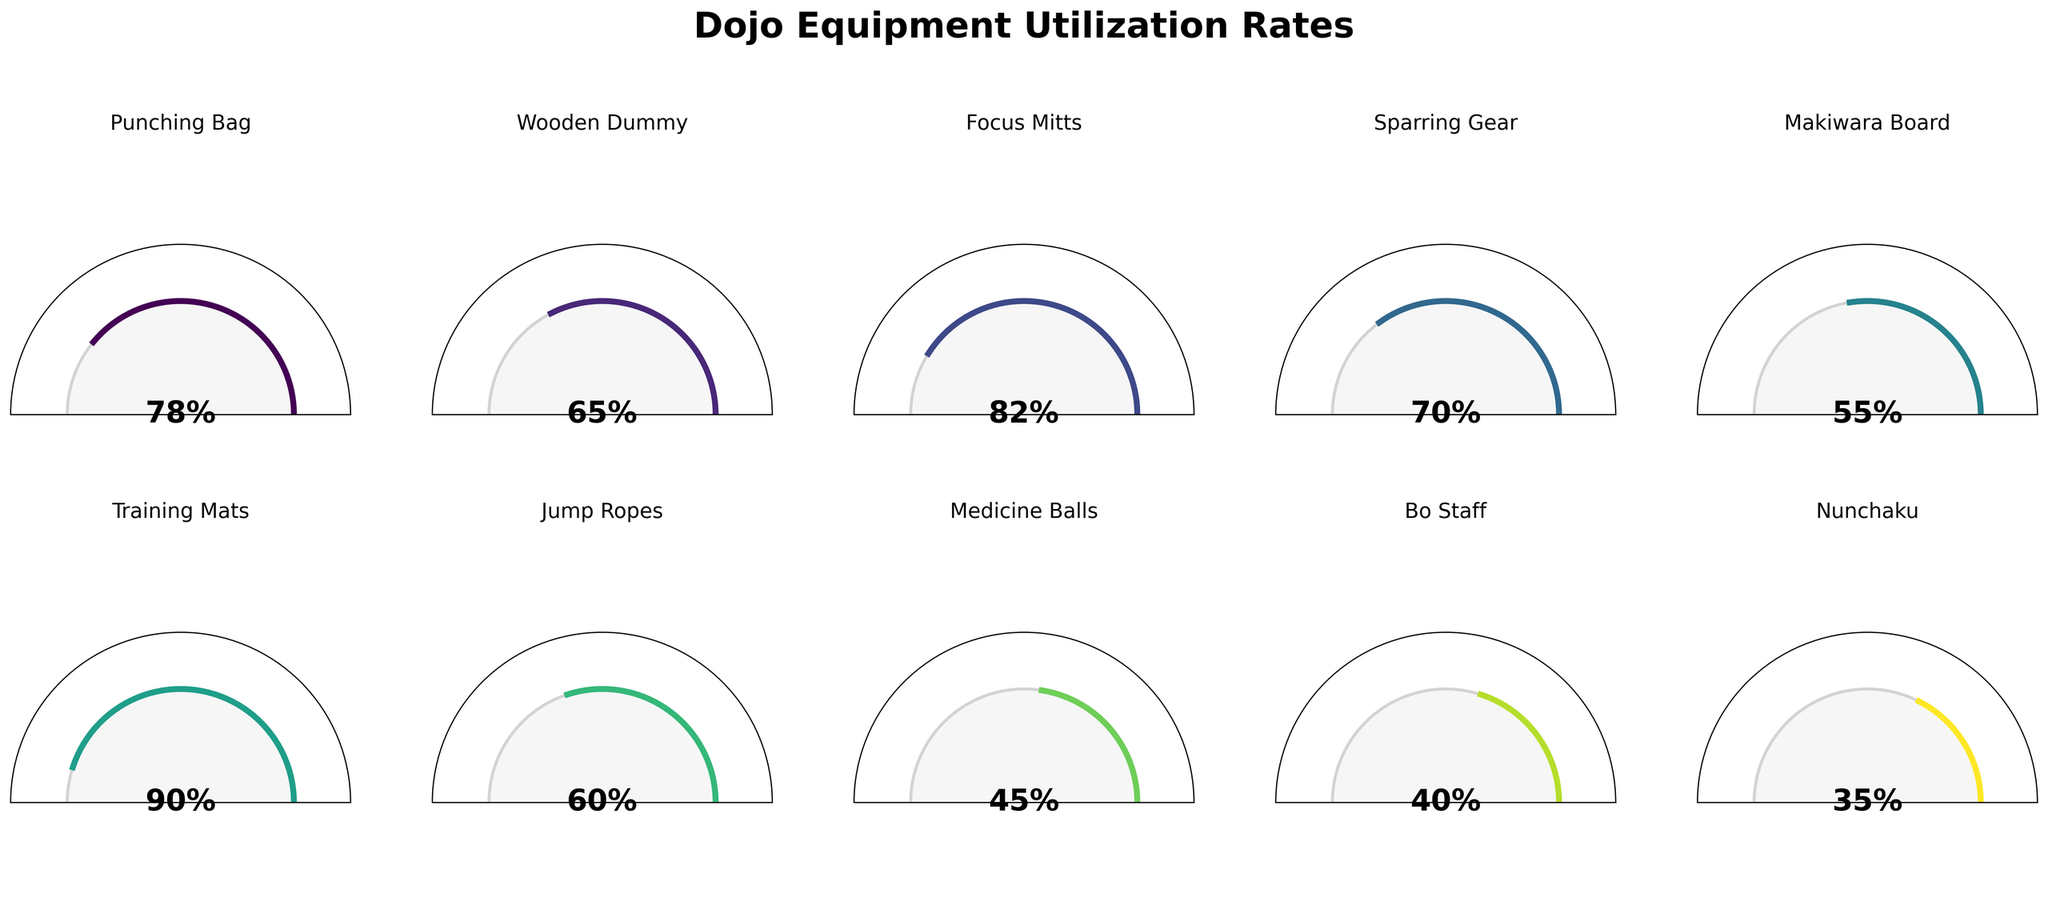What is the utilization rate of the Training Mats? The gauge chart for Training Mats shows a value at the center, which is 90%.
Answer: 90% Which equipment has the lowest utilization rate? By scanning through all the gauge charts, the lowest value at the center is for the Nunchaku, which is 35%.
Answer: Nunchaku What is the average utilization rate of all the training tools? Add up all the utilization rates: 78 + 65 + 82 + 70 + 55 + 90 + 60 + 45 + 40 + 35 = 620. There are 10 training tools, so the average rate is 620 / 10 = 62%.
Answer: 62% Which equipment has a higher utilization rate than the Bo Staff but lower than the Training Mats? The Bo Staff has a utilization rate of 40%, and the Training Mats have a rate of 90%. By examining the chart, Punching Bag (78%), Wooden Dummy (65%), Focus Mitts (82%), Sparring Gear (70%), and Jump Ropes (60%) all fit this criterion.
Answer: Punching Bag, Wooden Dummy, Focus Mitts, Sparring Gear, Jump Ropes How many pieces of equipment have a utilization rate above 70%? By checking the gauge charts, Punching Bag (78%), Focus Mitts (82%), Sparring Gear (70%), and Training Mats (90%) all have rates above 70%. Therefore, there are 4 pieces of equipment.
Answer: 4 What is the combined utilization rate of the Medicine Balls and Jump Ropes? The utilization rate for Medicine Balls is 45%, and for Jump Ropes, it is 60%. Adding these rates together results in 45 + 60 = 105%.
Answer: 105% Which equipment has a utilization rate closest to 50%? By looking at the specific values, Makiwara Board, with a utilization rate of 55%, is the closest to 50%.
Answer: Makiwara Board Between the Punching Bag and the Focus Mitts, which one has a higher utilization rate? The utilization rate for the Punching Bag is 78%, and for the Focus Mitts, it is 82%. Therefore, Focus Mitts have a higher utilization rate.
Answer: Focus Mitts What is the difference in utilization rate between the Wooden Dummy and Medicine Balls? The Wooden Dummy has a utilization rate of 65%, and the Medicine Balls have a rate of 45%. The difference is 65 - 45 = 20%.
Answer: 20% Which equipment's utilization rate is exactly half of another piece of equipment's rate? By examining the gauge charts and performing divisions, the Nunchaku has a 35% utilization rate, which is exactly half of the Training Mats' rate at 90%.
Answer: Nunchaku, Training Mats 